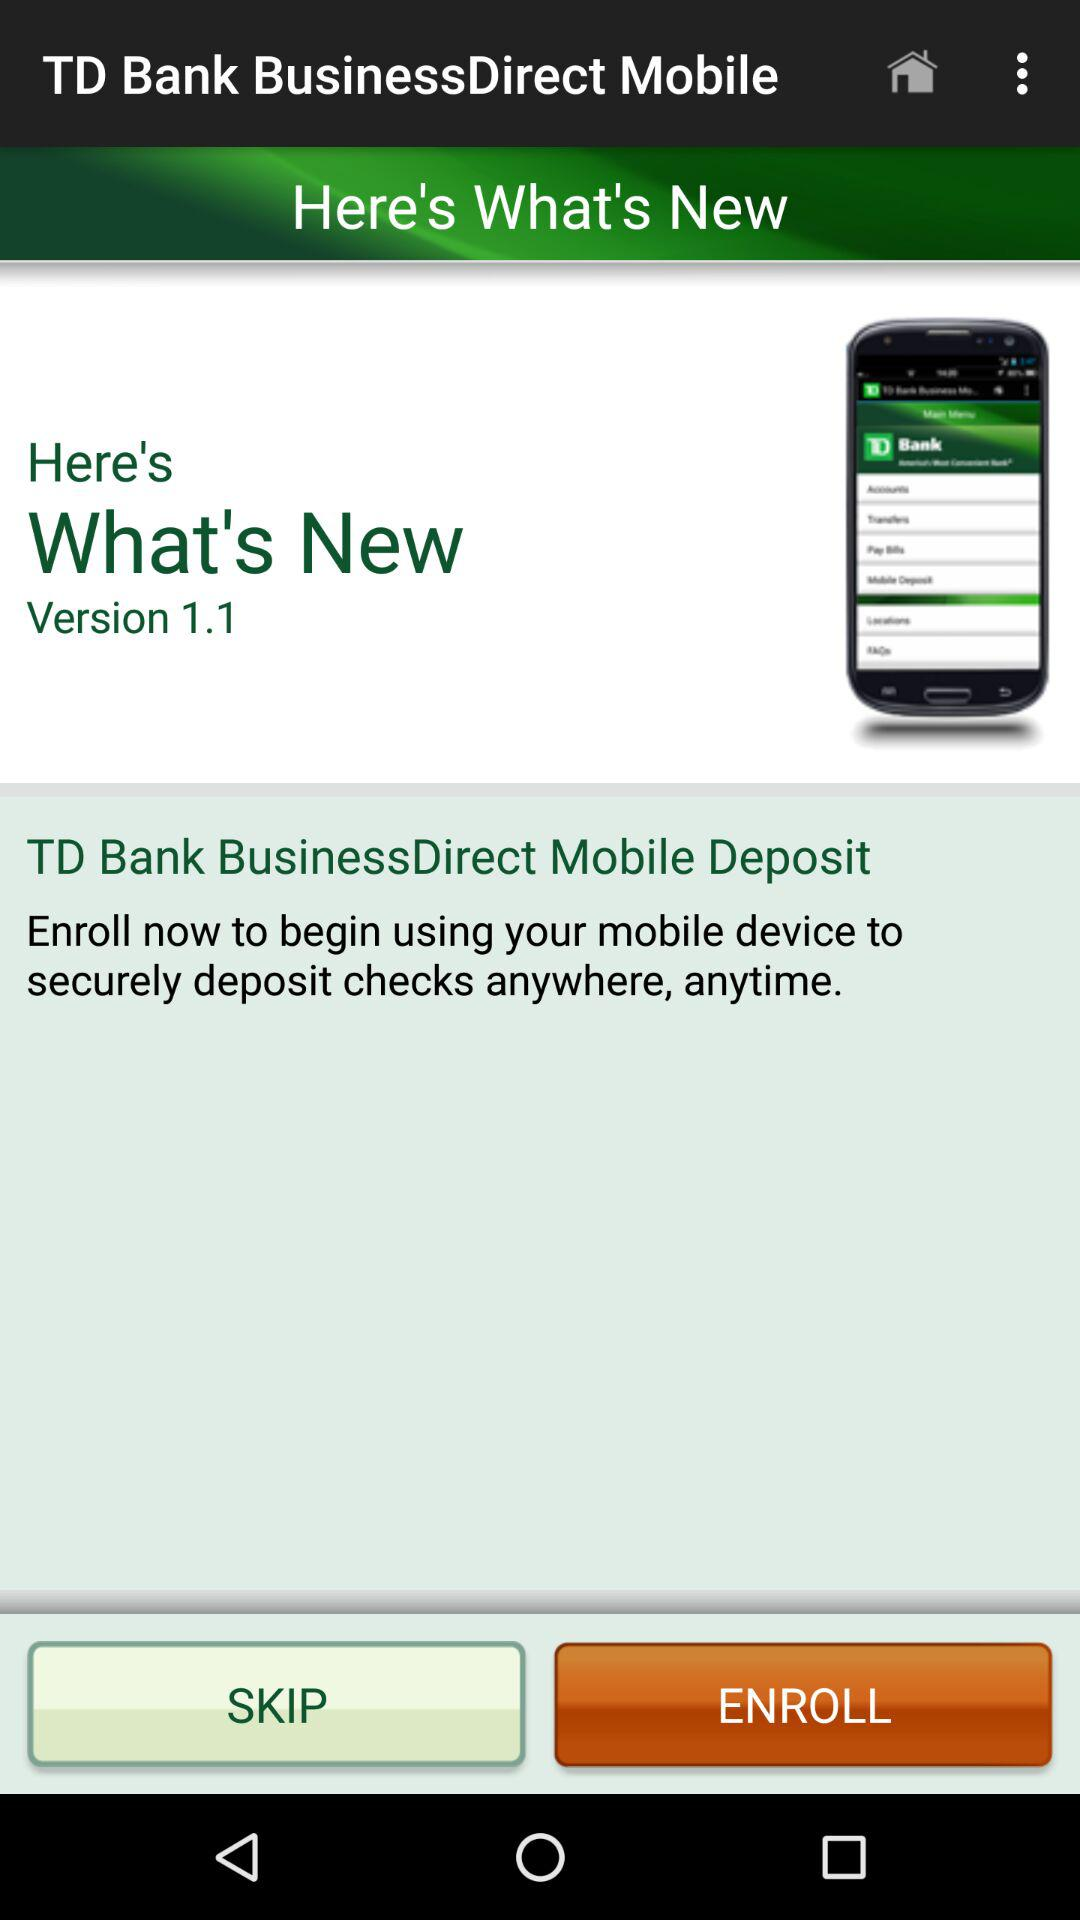How many versions of the app are there?
Answer the question using a single word or phrase. 1.1 